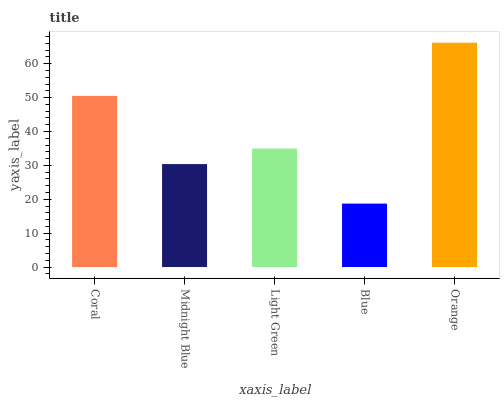Is Blue the minimum?
Answer yes or no. Yes. Is Orange the maximum?
Answer yes or no. Yes. Is Midnight Blue the minimum?
Answer yes or no. No. Is Midnight Blue the maximum?
Answer yes or no. No. Is Coral greater than Midnight Blue?
Answer yes or no. Yes. Is Midnight Blue less than Coral?
Answer yes or no. Yes. Is Midnight Blue greater than Coral?
Answer yes or no. No. Is Coral less than Midnight Blue?
Answer yes or no. No. Is Light Green the high median?
Answer yes or no. Yes. Is Light Green the low median?
Answer yes or no. Yes. Is Blue the high median?
Answer yes or no. No. Is Midnight Blue the low median?
Answer yes or no. No. 